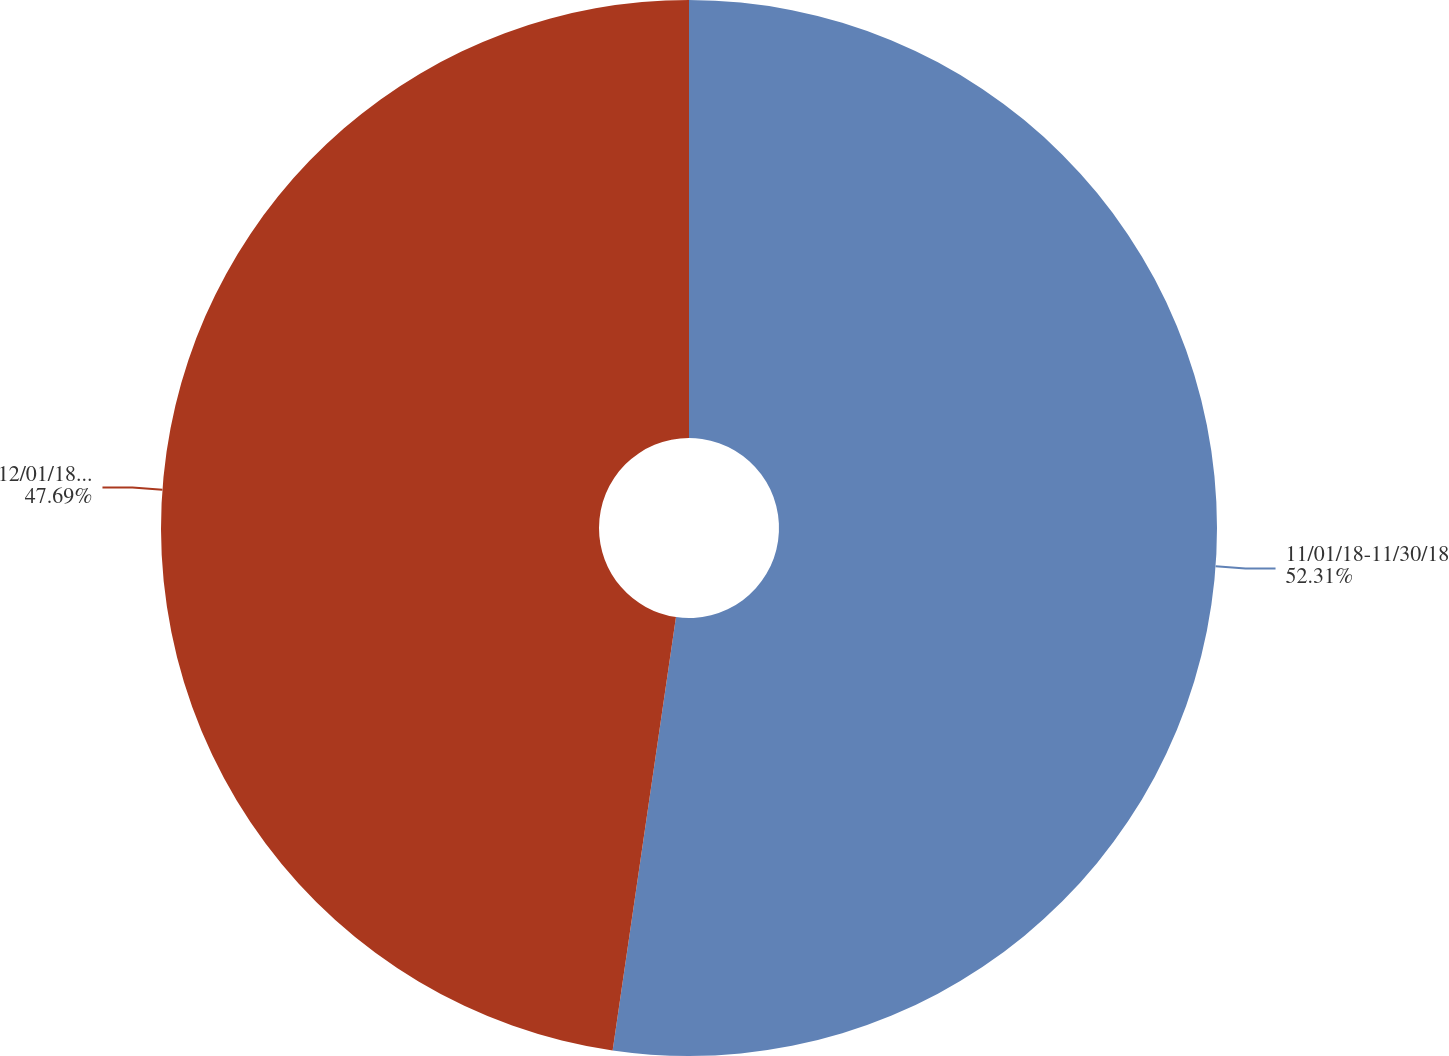Convert chart. <chart><loc_0><loc_0><loc_500><loc_500><pie_chart><fcel>11/01/18-11/30/18<fcel>12/01/18-12/31/18<nl><fcel>52.31%<fcel>47.69%<nl></chart> 